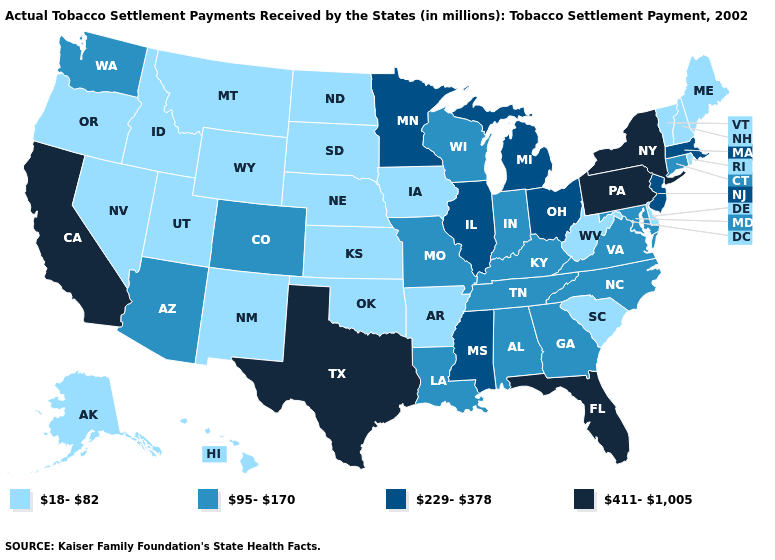Is the legend a continuous bar?
Be succinct. No. What is the value of Hawaii?
Short answer required. 18-82. Does Alaska have the highest value in the West?
Keep it brief. No. Name the states that have a value in the range 18-82?
Short answer required. Alaska, Arkansas, Delaware, Hawaii, Idaho, Iowa, Kansas, Maine, Montana, Nebraska, Nevada, New Hampshire, New Mexico, North Dakota, Oklahoma, Oregon, Rhode Island, South Carolina, South Dakota, Utah, Vermont, West Virginia, Wyoming. Does Mississippi have a higher value than Maine?
Give a very brief answer. Yes. Does North Carolina have the lowest value in the USA?
Quick response, please. No. What is the value of South Dakota?
Keep it brief. 18-82. Among the states that border Mississippi , which have the lowest value?
Be succinct. Arkansas. Among the states that border Florida , which have the highest value?
Quick response, please. Alabama, Georgia. Does the first symbol in the legend represent the smallest category?
Write a very short answer. Yes. What is the lowest value in the South?
Give a very brief answer. 18-82. Name the states that have a value in the range 229-378?
Answer briefly. Illinois, Massachusetts, Michigan, Minnesota, Mississippi, New Jersey, Ohio. Name the states that have a value in the range 229-378?
Be succinct. Illinois, Massachusetts, Michigan, Minnesota, Mississippi, New Jersey, Ohio. Does New Hampshire have a lower value than Rhode Island?
Write a very short answer. No. What is the value of Illinois?
Quick response, please. 229-378. 